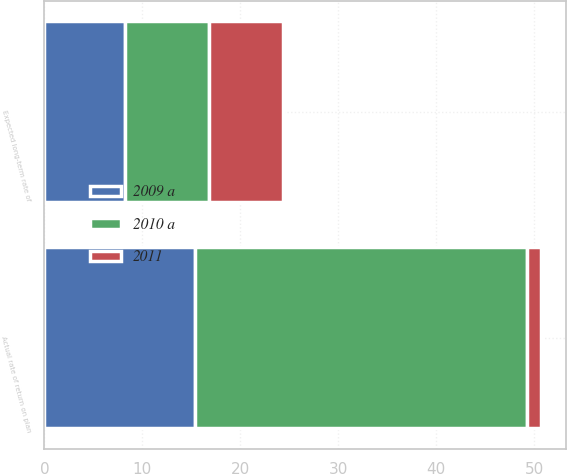Convert chart to OTSL. <chart><loc_0><loc_0><loc_500><loc_500><stacked_bar_chart><ecel><fcel>Expected long-term rate of<fcel>Actual rate of return on plan<nl><fcel>2011<fcel>7.52<fcel>1.4<nl><fcel>2009 a<fcel>8.2<fcel>15.34<nl><fcel>2010 a<fcel>8.63<fcel>33.96<nl></chart> 